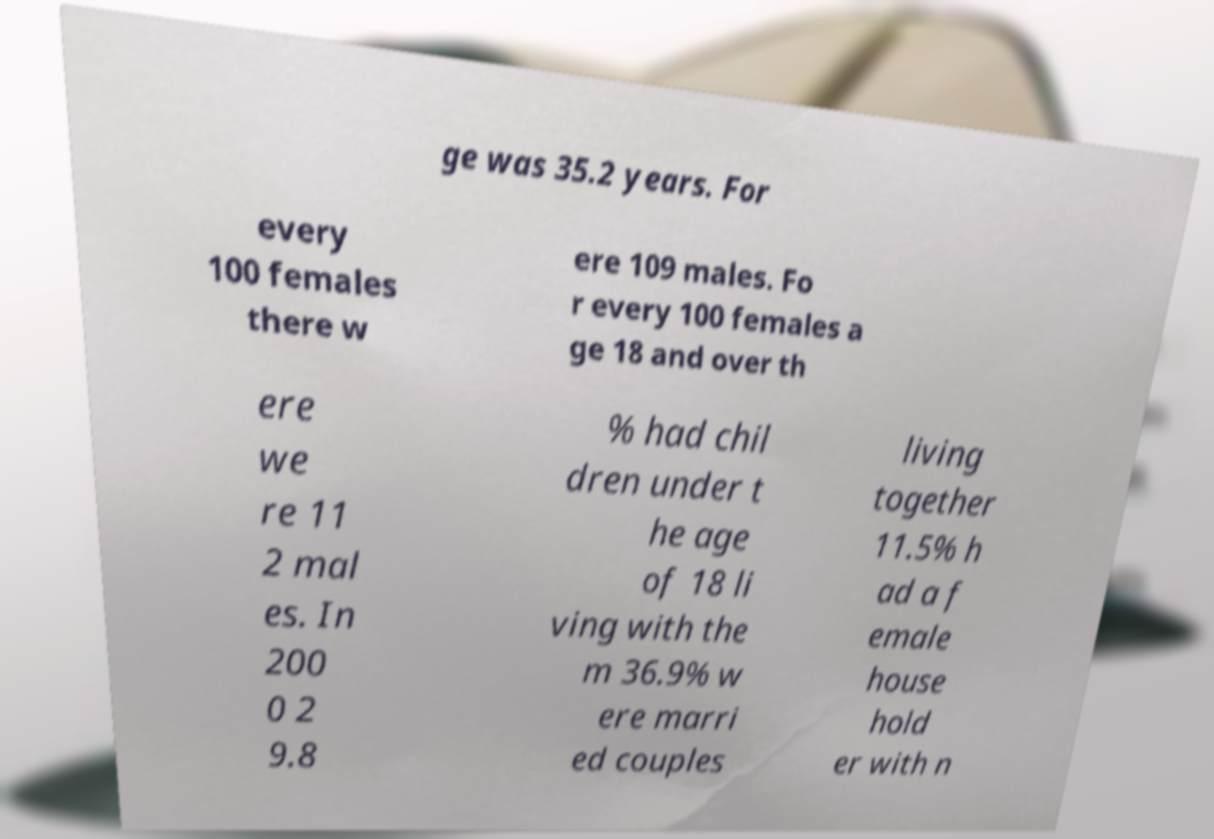Could you assist in decoding the text presented in this image and type it out clearly? ge was 35.2 years. For every 100 females there w ere 109 males. Fo r every 100 females a ge 18 and over th ere we re 11 2 mal es. In 200 0 2 9.8 % had chil dren under t he age of 18 li ving with the m 36.9% w ere marri ed couples living together 11.5% h ad a f emale house hold er with n 